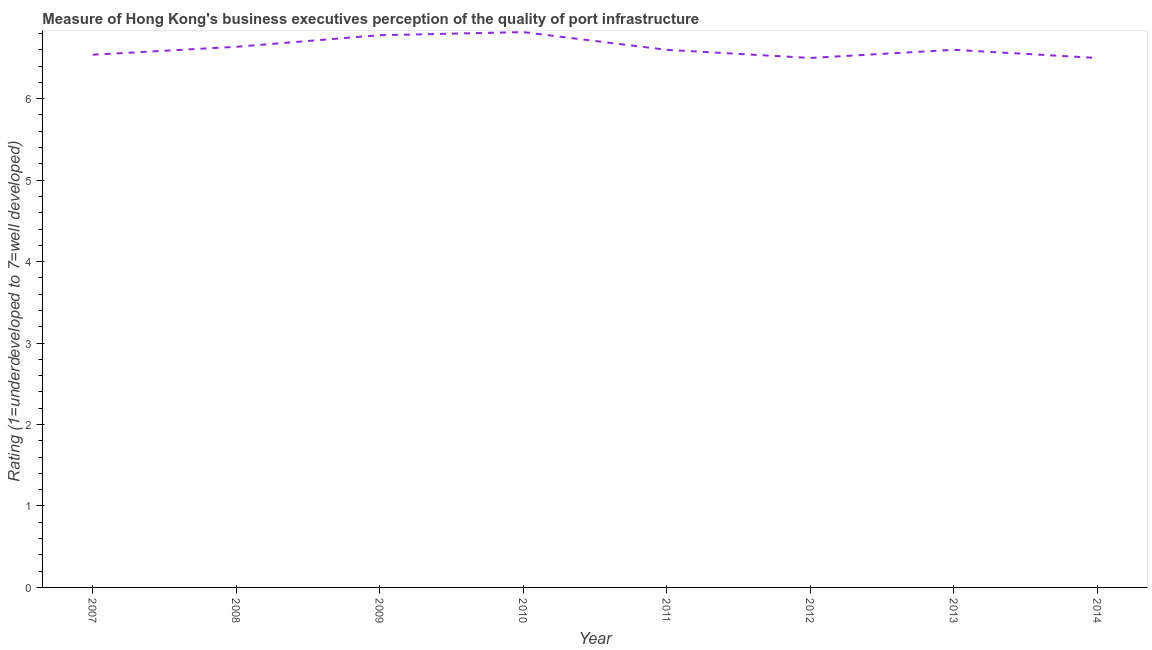What is the rating measuring quality of port infrastructure in 2007?
Your answer should be compact. 6.54. Across all years, what is the maximum rating measuring quality of port infrastructure?
Your response must be concise. 6.82. Across all years, what is the minimum rating measuring quality of port infrastructure?
Offer a terse response. 6.5. In which year was the rating measuring quality of port infrastructure maximum?
Provide a short and direct response. 2010. In which year was the rating measuring quality of port infrastructure minimum?
Your answer should be compact. 2012. What is the sum of the rating measuring quality of port infrastructure?
Offer a terse response. 52.97. What is the difference between the rating measuring quality of port infrastructure in 2009 and 2011?
Keep it short and to the point. 0.18. What is the average rating measuring quality of port infrastructure per year?
Offer a very short reply. 6.62. Do a majority of the years between 2010 and 2011 (inclusive) have rating measuring quality of port infrastructure greater than 3 ?
Provide a short and direct response. Yes. What is the ratio of the rating measuring quality of port infrastructure in 2009 to that in 2011?
Make the answer very short. 1.03. Is the difference between the rating measuring quality of port infrastructure in 2008 and 2009 greater than the difference between any two years?
Ensure brevity in your answer.  No. What is the difference between the highest and the second highest rating measuring quality of port infrastructure?
Give a very brief answer. 0.04. What is the difference between the highest and the lowest rating measuring quality of port infrastructure?
Your answer should be compact. 0.32. Does the rating measuring quality of port infrastructure monotonically increase over the years?
Your answer should be compact. No. What is the difference between two consecutive major ticks on the Y-axis?
Keep it short and to the point. 1. Are the values on the major ticks of Y-axis written in scientific E-notation?
Ensure brevity in your answer.  No. Does the graph contain any zero values?
Provide a short and direct response. No. What is the title of the graph?
Offer a terse response. Measure of Hong Kong's business executives perception of the quality of port infrastructure. What is the label or title of the Y-axis?
Keep it short and to the point. Rating (1=underdeveloped to 7=well developed) . What is the Rating (1=underdeveloped to 7=well developed)  of 2007?
Your response must be concise. 6.54. What is the Rating (1=underdeveloped to 7=well developed)  of 2008?
Your answer should be very brief. 6.64. What is the Rating (1=underdeveloped to 7=well developed)  in 2009?
Provide a succinct answer. 6.78. What is the Rating (1=underdeveloped to 7=well developed)  of 2010?
Your response must be concise. 6.82. What is the Rating (1=underdeveloped to 7=well developed)  of 2011?
Your response must be concise. 6.6. What is the Rating (1=underdeveloped to 7=well developed)  in 2014?
Make the answer very short. 6.5. What is the difference between the Rating (1=underdeveloped to 7=well developed)  in 2007 and 2008?
Your answer should be very brief. -0.1. What is the difference between the Rating (1=underdeveloped to 7=well developed)  in 2007 and 2009?
Provide a succinct answer. -0.24. What is the difference between the Rating (1=underdeveloped to 7=well developed)  in 2007 and 2010?
Your response must be concise. -0.28. What is the difference between the Rating (1=underdeveloped to 7=well developed)  in 2007 and 2011?
Your response must be concise. -0.06. What is the difference between the Rating (1=underdeveloped to 7=well developed)  in 2007 and 2012?
Make the answer very short. 0.04. What is the difference between the Rating (1=underdeveloped to 7=well developed)  in 2007 and 2013?
Offer a very short reply. -0.06. What is the difference between the Rating (1=underdeveloped to 7=well developed)  in 2007 and 2014?
Your answer should be compact. 0.04. What is the difference between the Rating (1=underdeveloped to 7=well developed)  in 2008 and 2009?
Offer a very short reply. -0.14. What is the difference between the Rating (1=underdeveloped to 7=well developed)  in 2008 and 2010?
Your response must be concise. -0.18. What is the difference between the Rating (1=underdeveloped to 7=well developed)  in 2008 and 2011?
Your response must be concise. 0.04. What is the difference between the Rating (1=underdeveloped to 7=well developed)  in 2008 and 2012?
Ensure brevity in your answer.  0.14. What is the difference between the Rating (1=underdeveloped to 7=well developed)  in 2008 and 2013?
Keep it short and to the point. 0.04. What is the difference between the Rating (1=underdeveloped to 7=well developed)  in 2008 and 2014?
Provide a succinct answer. 0.14. What is the difference between the Rating (1=underdeveloped to 7=well developed)  in 2009 and 2010?
Provide a short and direct response. -0.04. What is the difference between the Rating (1=underdeveloped to 7=well developed)  in 2009 and 2011?
Provide a succinct answer. 0.18. What is the difference between the Rating (1=underdeveloped to 7=well developed)  in 2009 and 2012?
Make the answer very short. 0.28. What is the difference between the Rating (1=underdeveloped to 7=well developed)  in 2009 and 2013?
Give a very brief answer. 0.18. What is the difference between the Rating (1=underdeveloped to 7=well developed)  in 2009 and 2014?
Give a very brief answer. 0.28. What is the difference between the Rating (1=underdeveloped to 7=well developed)  in 2010 and 2011?
Provide a succinct answer. 0.22. What is the difference between the Rating (1=underdeveloped to 7=well developed)  in 2010 and 2012?
Provide a short and direct response. 0.32. What is the difference between the Rating (1=underdeveloped to 7=well developed)  in 2010 and 2013?
Offer a terse response. 0.22. What is the difference between the Rating (1=underdeveloped to 7=well developed)  in 2010 and 2014?
Provide a short and direct response. 0.32. What is the difference between the Rating (1=underdeveloped to 7=well developed)  in 2011 and 2012?
Offer a very short reply. 0.1. What is the ratio of the Rating (1=underdeveloped to 7=well developed)  in 2007 to that in 2009?
Offer a very short reply. 0.96. What is the ratio of the Rating (1=underdeveloped to 7=well developed)  in 2007 to that in 2013?
Offer a very short reply. 0.99. What is the ratio of the Rating (1=underdeveloped to 7=well developed)  in 2008 to that in 2012?
Your answer should be very brief. 1.02. What is the ratio of the Rating (1=underdeveloped to 7=well developed)  in 2008 to that in 2013?
Provide a short and direct response. 1.01. What is the ratio of the Rating (1=underdeveloped to 7=well developed)  in 2009 to that in 2010?
Your answer should be very brief. 0.99. What is the ratio of the Rating (1=underdeveloped to 7=well developed)  in 2009 to that in 2012?
Ensure brevity in your answer.  1.04. What is the ratio of the Rating (1=underdeveloped to 7=well developed)  in 2009 to that in 2014?
Ensure brevity in your answer.  1.04. What is the ratio of the Rating (1=underdeveloped to 7=well developed)  in 2010 to that in 2011?
Make the answer very short. 1.03. What is the ratio of the Rating (1=underdeveloped to 7=well developed)  in 2010 to that in 2012?
Your answer should be very brief. 1.05. What is the ratio of the Rating (1=underdeveloped to 7=well developed)  in 2010 to that in 2013?
Provide a short and direct response. 1.03. What is the ratio of the Rating (1=underdeveloped to 7=well developed)  in 2010 to that in 2014?
Keep it short and to the point. 1.05. What is the ratio of the Rating (1=underdeveloped to 7=well developed)  in 2011 to that in 2012?
Provide a succinct answer. 1.01. What is the ratio of the Rating (1=underdeveloped to 7=well developed)  in 2011 to that in 2013?
Your response must be concise. 1. 